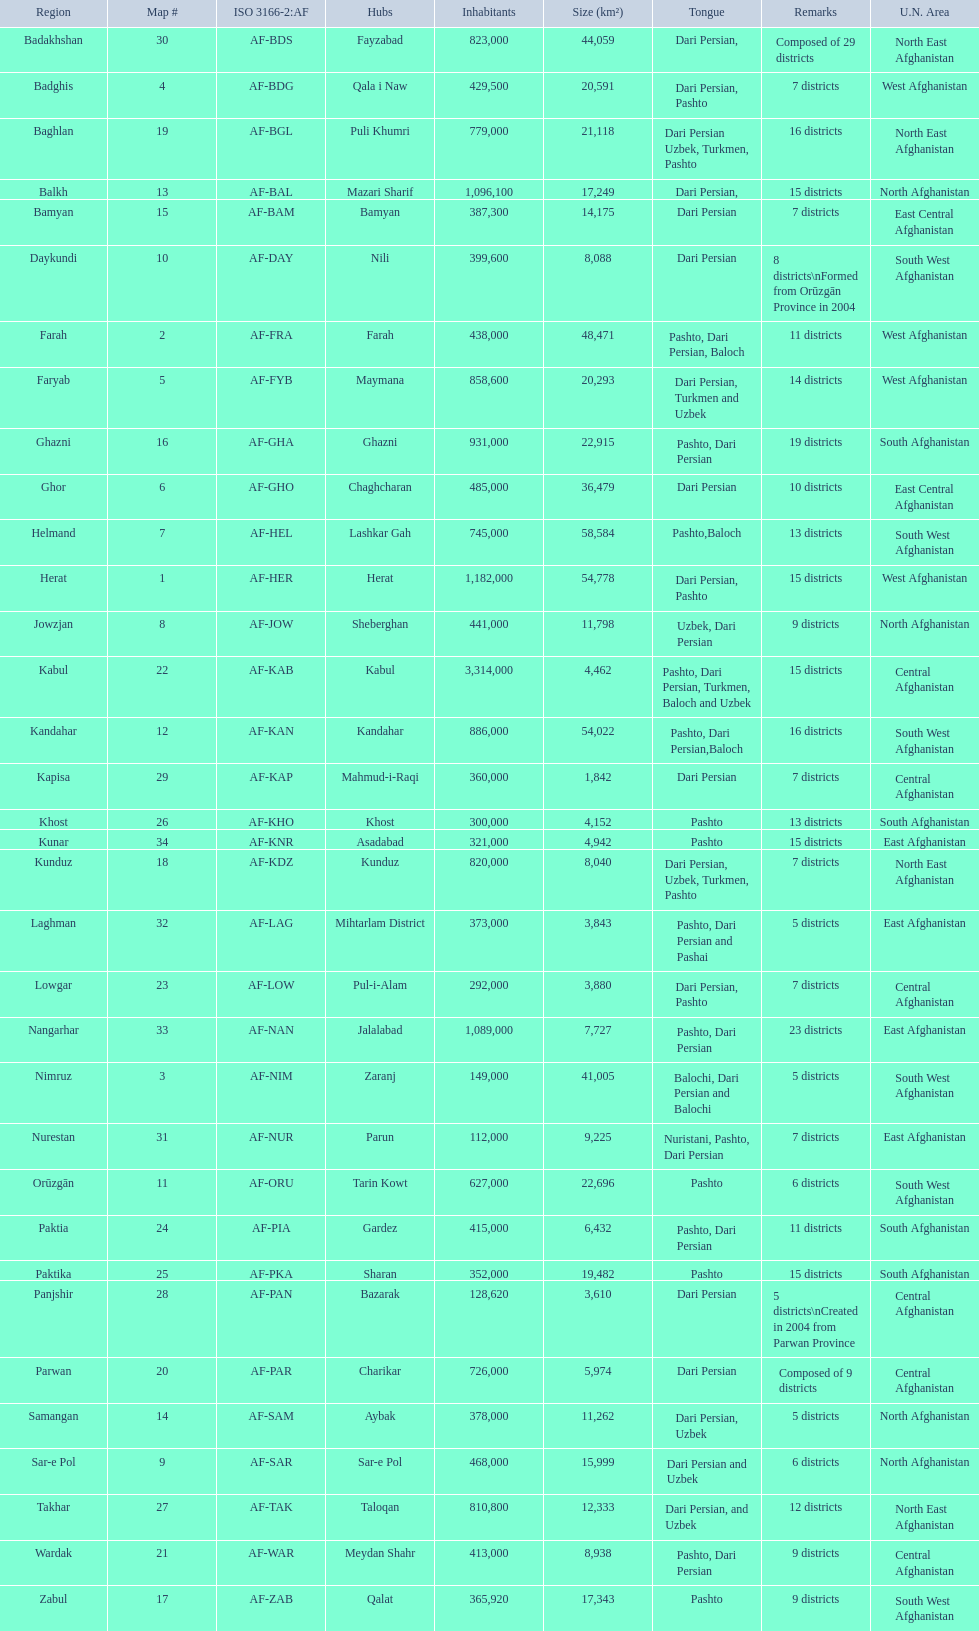In which province does the largest quantity of districts exist? Badakhshan. 